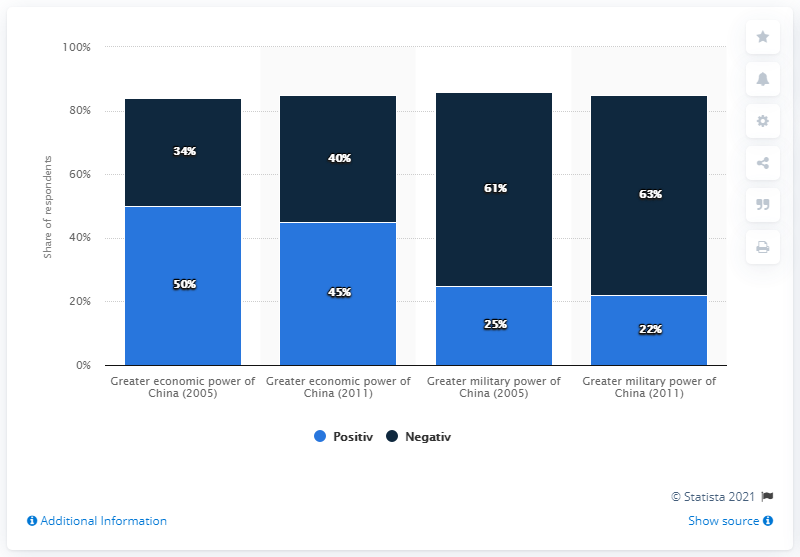Indicate a few pertinent items in this graphic. The average positive military power of China is estimated to be 35.5. The economic power of China reached its lowest point in 2011, while its military power was also positive during that year. 